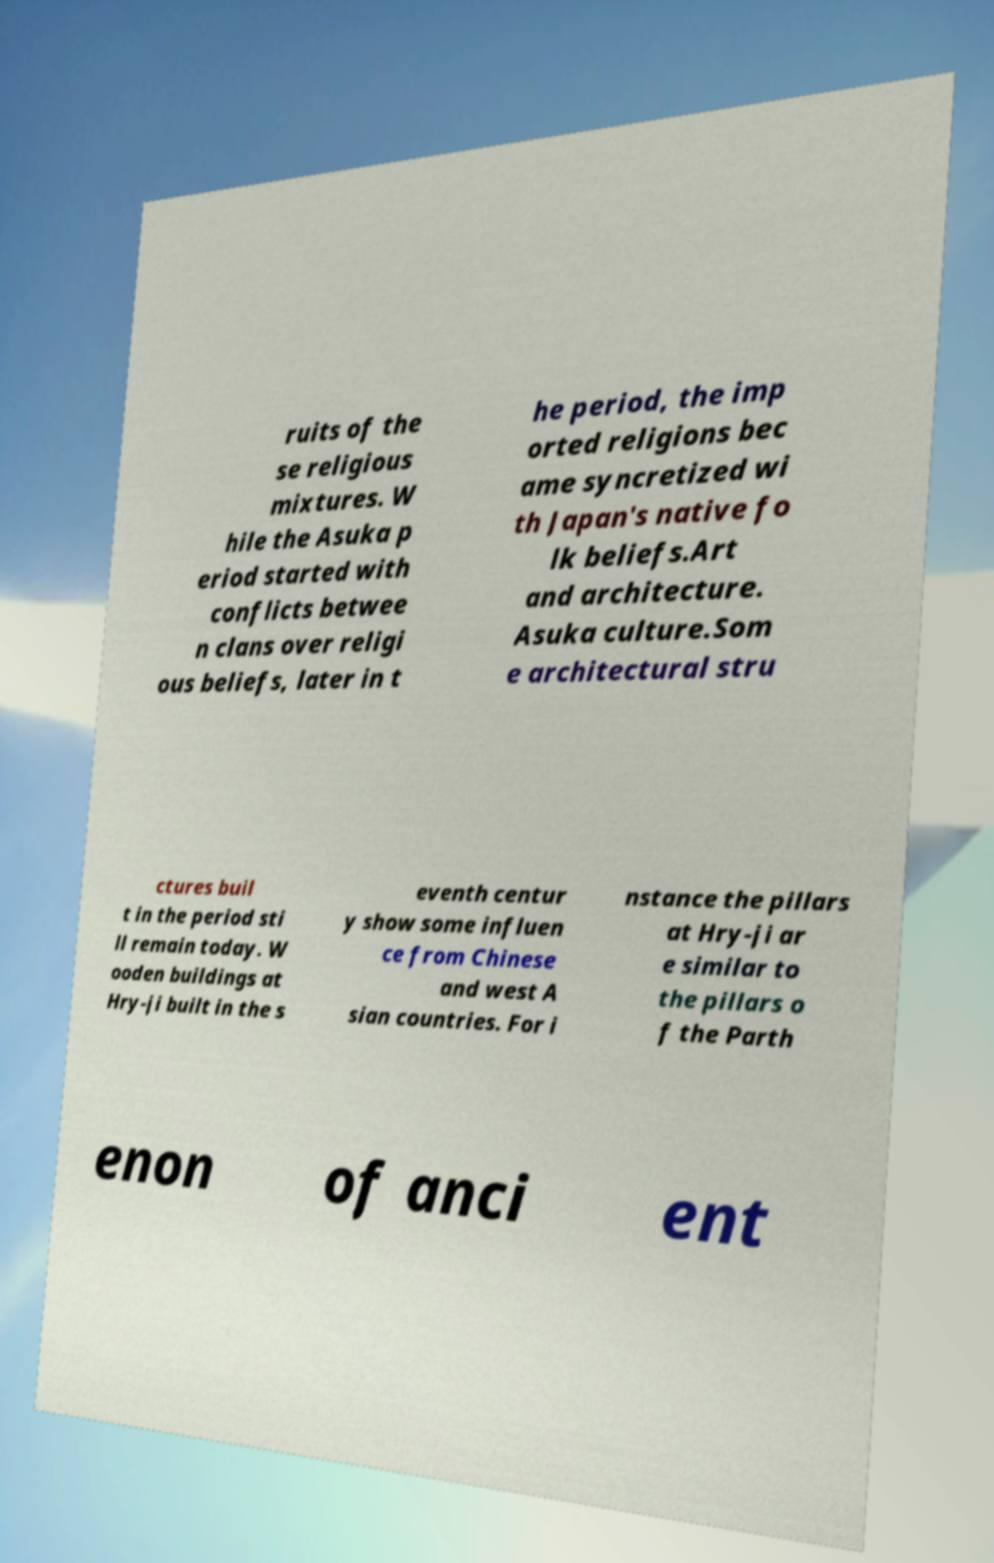Can you read and provide the text displayed in the image?This photo seems to have some interesting text. Can you extract and type it out for me? ruits of the se religious mixtures. W hile the Asuka p eriod started with conflicts betwee n clans over religi ous beliefs, later in t he period, the imp orted religions bec ame syncretized wi th Japan's native fo lk beliefs.Art and architecture. Asuka culture.Som e architectural stru ctures buil t in the period sti ll remain today. W ooden buildings at Hry-ji built in the s eventh centur y show some influen ce from Chinese and west A sian countries. For i nstance the pillars at Hry-ji ar e similar to the pillars o f the Parth enon of anci ent 